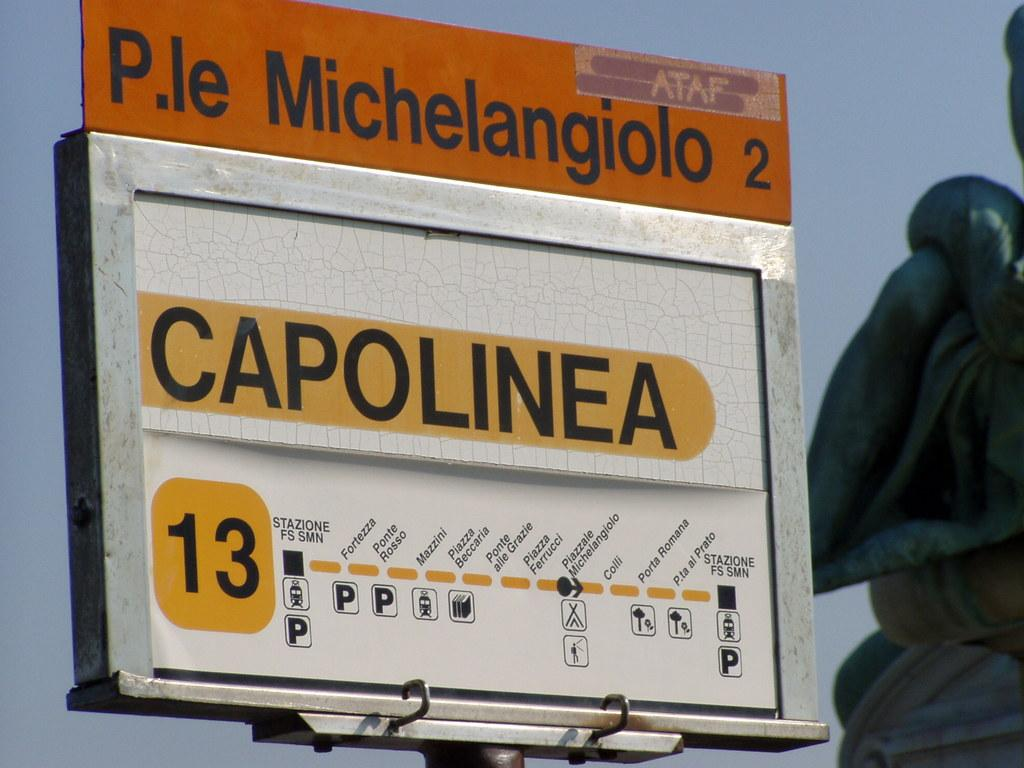Provide a one-sentence caption for the provided image. A sign that states P.le Michelangiolo 2 and Capolinea. 